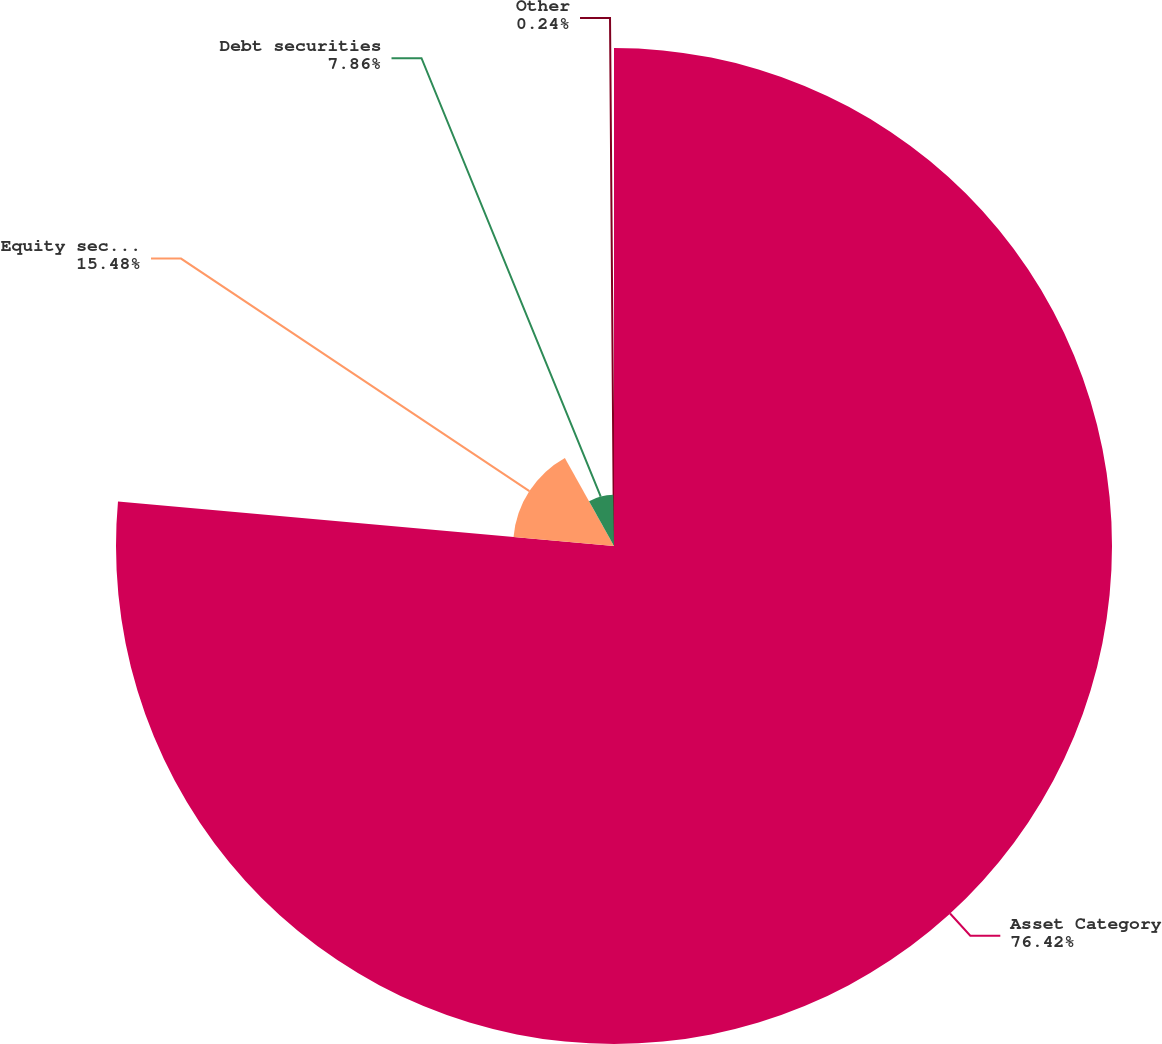Convert chart to OTSL. <chart><loc_0><loc_0><loc_500><loc_500><pie_chart><fcel>Asset Category<fcel>Equity securities<fcel>Debt securities<fcel>Other<nl><fcel>76.43%<fcel>15.48%<fcel>7.86%<fcel>0.24%<nl></chart> 